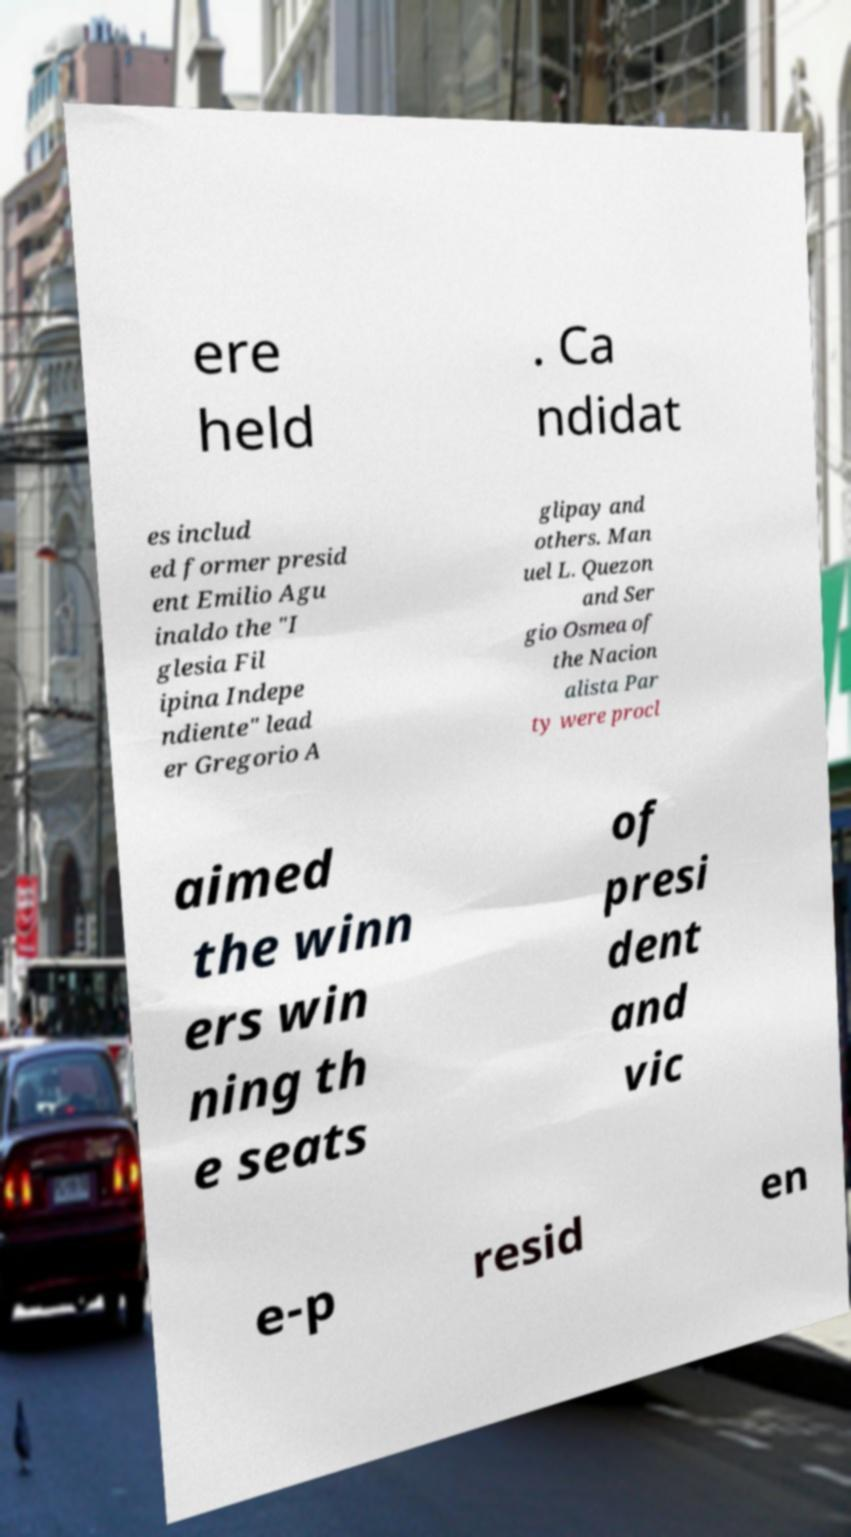Please identify and transcribe the text found in this image. ere held . Ca ndidat es includ ed former presid ent Emilio Agu inaldo the "I glesia Fil ipina Indepe ndiente" lead er Gregorio A glipay and others. Man uel L. Quezon and Ser gio Osmea of the Nacion alista Par ty were procl aimed the winn ers win ning th e seats of presi dent and vic e-p resid en 